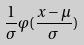Convert formula to latex. <formula><loc_0><loc_0><loc_500><loc_500>\frac { 1 } { \sigma } \varphi ( \frac { x - \mu } { \sigma } )</formula> 